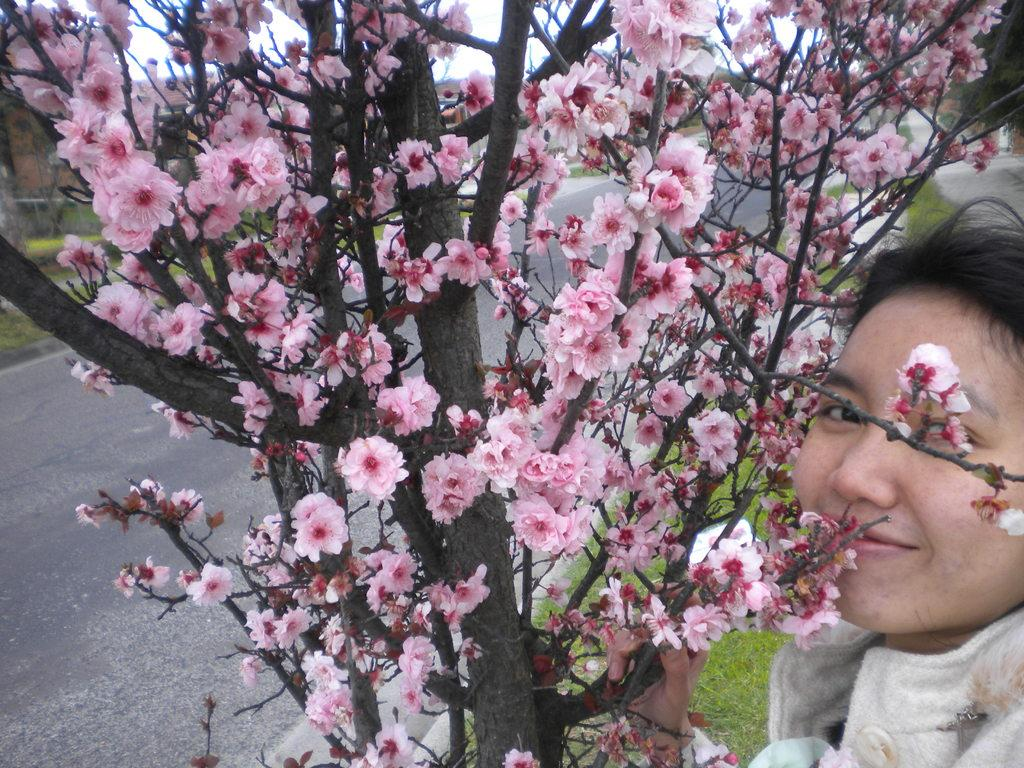What can be seen in the background of the image? The sky is visible in the image. What is located on the ground in the image? There is a road and grass in the image. What type of plant is present in the image? There is a tree with flowers in the image. Can you describe the person in the image? There is a person in the image, truncated towards the right side. What type of shock can be seen on the person's face in the image? There is no shock visible on the person's face in the image, as their face is not fully visible. 